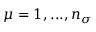<formula> <loc_0><loc_0><loc_500><loc_500>\mu = 1 , \dots , n _ { \sigma }</formula> 